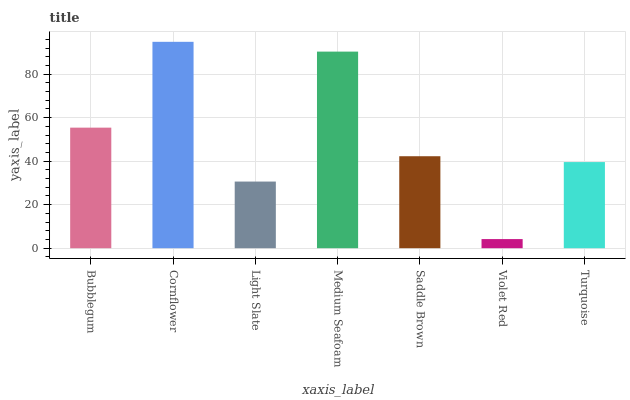Is Violet Red the minimum?
Answer yes or no. Yes. Is Cornflower the maximum?
Answer yes or no. Yes. Is Light Slate the minimum?
Answer yes or no. No. Is Light Slate the maximum?
Answer yes or no. No. Is Cornflower greater than Light Slate?
Answer yes or no. Yes. Is Light Slate less than Cornflower?
Answer yes or no. Yes. Is Light Slate greater than Cornflower?
Answer yes or no. No. Is Cornflower less than Light Slate?
Answer yes or no. No. Is Saddle Brown the high median?
Answer yes or no. Yes. Is Saddle Brown the low median?
Answer yes or no. Yes. Is Medium Seafoam the high median?
Answer yes or no. No. Is Bubblegum the low median?
Answer yes or no. No. 